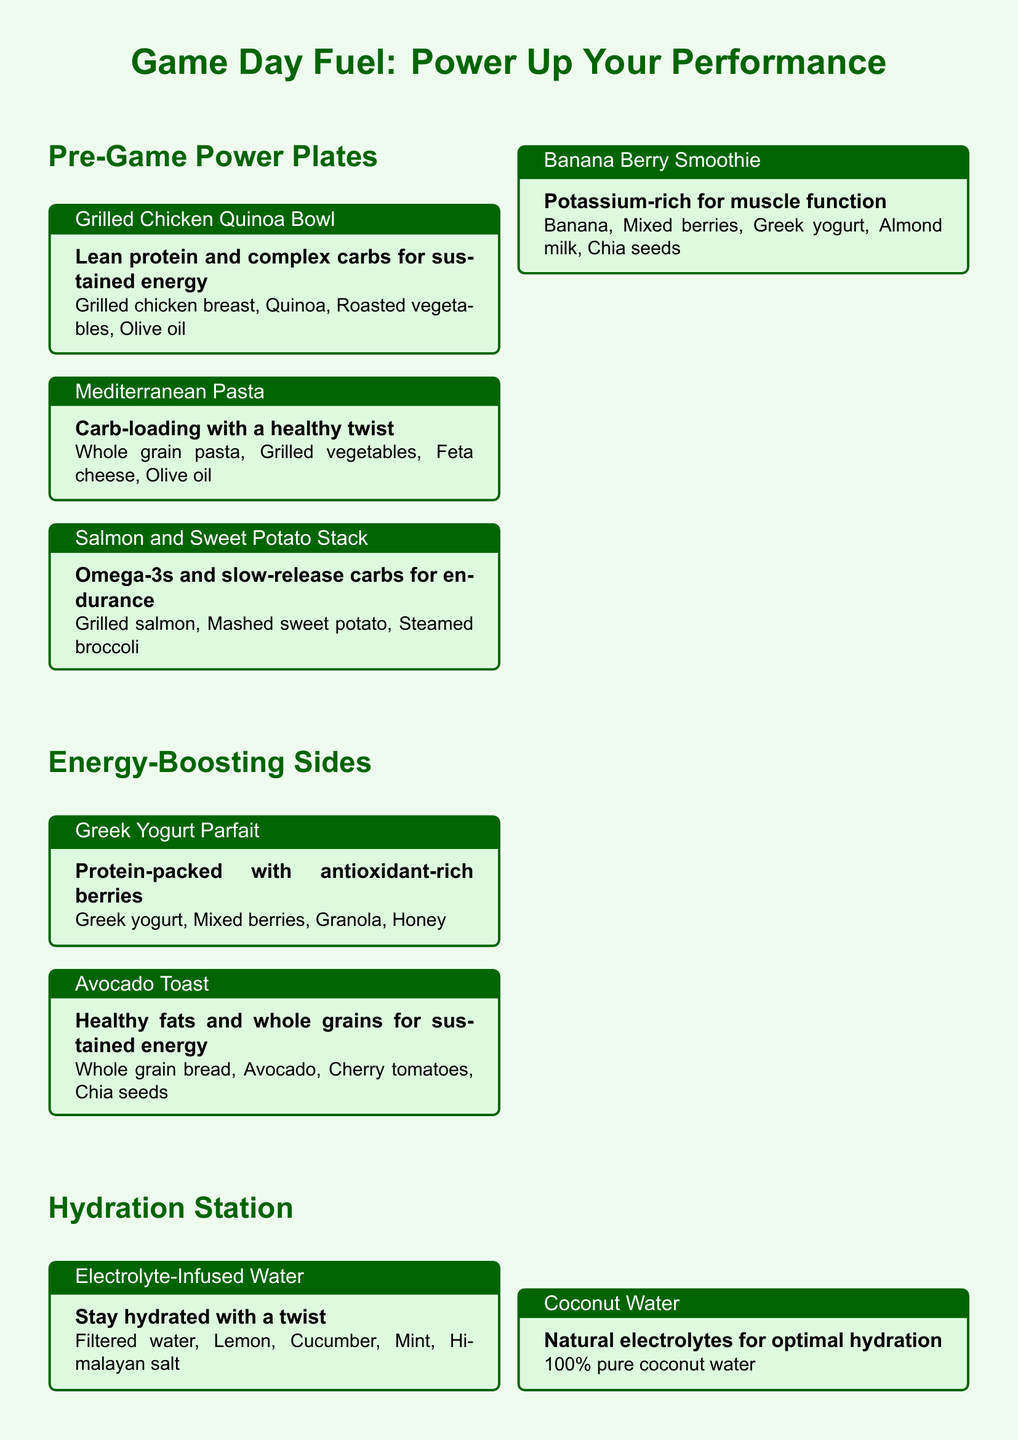What is the title of the menu? The title is the main heading that indicates the purpose of the document, which is "Game Day Fuel: Power Up Your Performance."
Answer: Game Day Fuel: Power Up Your Performance What are the ingredients in the Grilled Chicken Quinoa Bowl? The ingredients consist of grilled chicken breast, quinoa, roasted vegetables, and olive oil.
Answer: Grilled chicken breast, Quinoa, Roasted vegetables, Olive oil Which dish contains Omega-3s? The dish that contains Omega-3s is specifically mentioned in the title of the meal that includes salmon, which provides these nutrients.
Answer: Salmon and Sweet Potato Stack How much water should you drink before the game? The document specifies the amount of water recommended to be consumed before the game.
Answer: 16-20 oz What is the purpose of the Banana Berry Smoothie? The purpose of the Banana Berry Smoothie is to provide a potassium-rich option that supports muscle function.
Answer: Potassium-rich for muscle function Which ingredient is a source of healthy fats in the Avocado Toast? The primary ingredient that offers healthy fats in the Avocado Toast dish is clearly stated.
Answer: Avocado What type of pasta is used in the Mediterranean Pasta? The type of pasta specified in the Mediterranean dish is whole grain, as indicated in the description.
Answer: Whole grain pasta What is the hydration tip related to urine color? One of the hydration tips advises to monitor urine color, which helps assess hydration levels.
Answer: Pale yellow indicates good hydration What is the base of the Coconut Water? The base of the Coconut Water is indicated as being pure and natural, which is a notable characteristic.
Answer: 100% pure coconut water 